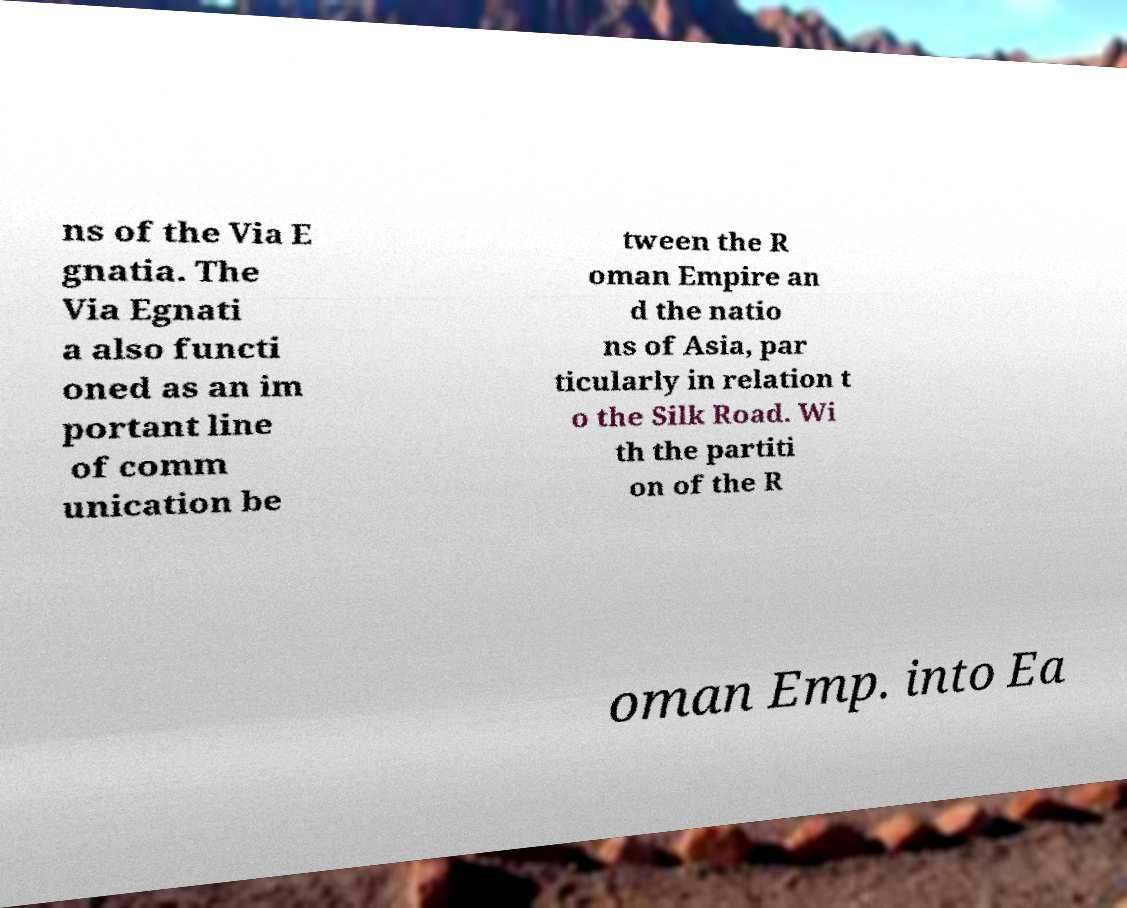What messages or text are displayed in this image? I need them in a readable, typed format. ns of the Via E gnatia. The Via Egnati a also functi oned as an im portant line of comm unication be tween the R oman Empire an d the natio ns of Asia, par ticularly in relation t o the Silk Road. Wi th the partiti on of the R oman Emp. into Ea 